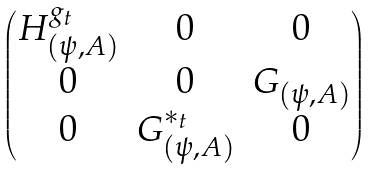Convert formula to latex. <formula><loc_0><loc_0><loc_500><loc_500>\begin{pmatrix} H _ { ( \psi , A ) } ^ { g _ { t } } & 0 & 0 \\ 0 & 0 & G _ { ( \psi , A ) } \\ 0 & G ^ { * _ { t } } _ { ( \psi , A ) } & 0 \end{pmatrix}</formula> 